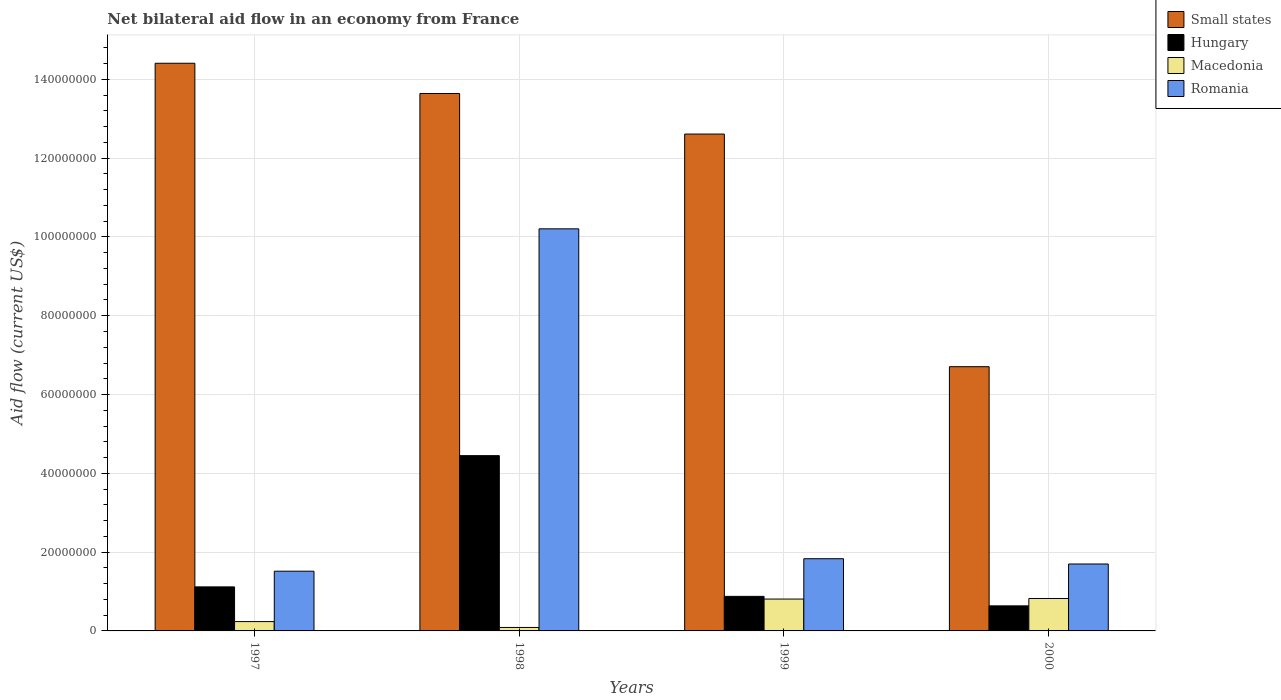How many different coloured bars are there?
Keep it short and to the point. 4. Are the number of bars per tick equal to the number of legend labels?
Keep it short and to the point. Yes. Are the number of bars on each tick of the X-axis equal?
Keep it short and to the point. Yes. How many bars are there on the 3rd tick from the left?
Provide a short and direct response. 4. How many bars are there on the 1st tick from the right?
Make the answer very short. 4. In how many cases, is the number of bars for a given year not equal to the number of legend labels?
Provide a short and direct response. 0. What is the net bilateral aid flow in Hungary in 1998?
Ensure brevity in your answer.  4.45e+07. Across all years, what is the maximum net bilateral aid flow in Small states?
Offer a very short reply. 1.44e+08. Across all years, what is the minimum net bilateral aid flow in Romania?
Offer a very short reply. 1.52e+07. In which year was the net bilateral aid flow in Macedonia maximum?
Your answer should be compact. 2000. What is the total net bilateral aid flow in Small states in the graph?
Ensure brevity in your answer.  4.74e+08. What is the difference between the net bilateral aid flow in Hungary in 1997 and that in 2000?
Give a very brief answer. 4.82e+06. What is the difference between the net bilateral aid flow in Romania in 1998 and the net bilateral aid flow in Hungary in 1999?
Provide a succinct answer. 9.33e+07. What is the average net bilateral aid flow in Romania per year?
Your response must be concise. 3.81e+07. In the year 1999, what is the difference between the net bilateral aid flow in Romania and net bilateral aid flow in Macedonia?
Give a very brief answer. 1.02e+07. In how many years, is the net bilateral aid flow in Small states greater than 60000000 US$?
Offer a terse response. 4. What is the ratio of the net bilateral aid flow in Hungary in 1998 to that in 1999?
Provide a short and direct response. 5.07. Is the net bilateral aid flow in Small states in 1998 less than that in 1999?
Offer a terse response. No. What is the difference between the highest and the lowest net bilateral aid flow in Macedonia?
Offer a very short reply. 7.35e+06. Is the sum of the net bilateral aid flow in Hungary in 1998 and 2000 greater than the maximum net bilateral aid flow in Small states across all years?
Your answer should be very brief. No. Is it the case that in every year, the sum of the net bilateral aid flow in Macedonia and net bilateral aid flow in Small states is greater than the sum of net bilateral aid flow in Romania and net bilateral aid flow in Hungary?
Your response must be concise. Yes. What does the 2nd bar from the left in 1998 represents?
Keep it short and to the point. Hungary. What does the 2nd bar from the right in 1997 represents?
Give a very brief answer. Macedonia. Is it the case that in every year, the sum of the net bilateral aid flow in Romania and net bilateral aid flow in Small states is greater than the net bilateral aid flow in Hungary?
Offer a very short reply. Yes. How many years are there in the graph?
Your answer should be compact. 4. What is the difference between two consecutive major ticks on the Y-axis?
Keep it short and to the point. 2.00e+07. Does the graph contain grids?
Offer a very short reply. Yes. Where does the legend appear in the graph?
Offer a terse response. Top right. What is the title of the graph?
Ensure brevity in your answer.  Net bilateral aid flow in an economy from France. What is the label or title of the Y-axis?
Offer a terse response. Aid flow (current US$). What is the Aid flow (current US$) in Small states in 1997?
Your response must be concise. 1.44e+08. What is the Aid flow (current US$) in Hungary in 1997?
Offer a terse response. 1.12e+07. What is the Aid flow (current US$) of Macedonia in 1997?
Your answer should be compact. 2.37e+06. What is the Aid flow (current US$) of Romania in 1997?
Offer a very short reply. 1.52e+07. What is the Aid flow (current US$) in Small states in 1998?
Keep it short and to the point. 1.36e+08. What is the Aid flow (current US$) in Hungary in 1998?
Your answer should be very brief. 4.45e+07. What is the Aid flow (current US$) in Macedonia in 1998?
Offer a very short reply. 8.80e+05. What is the Aid flow (current US$) in Romania in 1998?
Your answer should be compact. 1.02e+08. What is the Aid flow (current US$) in Small states in 1999?
Make the answer very short. 1.26e+08. What is the Aid flow (current US$) in Hungary in 1999?
Ensure brevity in your answer.  8.77e+06. What is the Aid flow (current US$) of Macedonia in 1999?
Your answer should be very brief. 8.09e+06. What is the Aid flow (current US$) of Romania in 1999?
Your response must be concise. 1.83e+07. What is the Aid flow (current US$) in Small states in 2000?
Ensure brevity in your answer.  6.71e+07. What is the Aid flow (current US$) in Hungary in 2000?
Offer a terse response. 6.36e+06. What is the Aid flow (current US$) in Macedonia in 2000?
Your answer should be compact. 8.23e+06. What is the Aid flow (current US$) of Romania in 2000?
Your response must be concise. 1.70e+07. Across all years, what is the maximum Aid flow (current US$) in Small states?
Give a very brief answer. 1.44e+08. Across all years, what is the maximum Aid flow (current US$) in Hungary?
Give a very brief answer. 4.45e+07. Across all years, what is the maximum Aid flow (current US$) in Macedonia?
Keep it short and to the point. 8.23e+06. Across all years, what is the maximum Aid flow (current US$) in Romania?
Make the answer very short. 1.02e+08. Across all years, what is the minimum Aid flow (current US$) of Small states?
Provide a short and direct response. 6.71e+07. Across all years, what is the minimum Aid flow (current US$) of Hungary?
Offer a very short reply. 6.36e+06. Across all years, what is the minimum Aid flow (current US$) in Macedonia?
Provide a succinct answer. 8.80e+05. Across all years, what is the minimum Aid flow (current US$) in Romania?
Provide a short and direct response. 1.52e+07. What is the total Aid flow (current US$) of Small states in the graph?
Offer a very short reply. 4.74e+08. What is the total Aid flow (current US$) of Hungary in the graph?
Give a very brief answer. 7.08e+07. What is the total Aid flow (current US$) of Macedonia in the graph?
Give a very brief answer. 1.96e+07. What is the total Aid flow (current US$) of Romania in the graph?
Your response must be concise. 1.53e+08. What is the difference between the Aid flow (current US$) of Small states in 1997 and that in 1998?
Give a very brief answer. 7.67e+06. What is the difference between the Aid flow (current US$) in Hungary in 1997 and that in 1998?
Ensure brevity in your answer.  -3.33e+07. What is the difference between the Aid flow (current US$) of Macedonia in 1997 and that in 1998?
Offer a very short reply. 1.49e+06. What is the difference between the Aid flow (current US$) of Romania in 1997 and that in 1998?
Make the answer very short. -8.69e+07. What is the difference between the Aid flow (current US$) of Small states in 1997 and that in 1999?
Provide a succinct answer. 1.80e+07. What is the difference between the Aid flow (current US$) of Hungary in 1997 and that in 1999?
Keep it short and to the point. 2.41e+06. What is the difference between the Aid flow (current US$) in Macedonia in 1997 and that in 1999?
Offer a very short reply. -5.72e+06. What is the difference between the Aid flow (current US$) in Romania in 1997 and that in 1999?
Offer a terse response. -3.17e+06. What is the difference between the Aid flow (current US$) of Small states in 1997 and that in 2000?
Provide a succinct answer. 7.70e+07. What is the difference between the Aid flow (current US$) in Hungary in 1997 and that in 2000?
Your answer should be very brief. 4.82e+06. What is the difference between the Aid flow (current US$) in Macedonia in 1997 and that in 2000?
Give a very brief answer. -5.86e+06. What is the difference between the Aid flow (current US$) in Romania in 1997 and that in 2000?
Provide a succinct answer. -1.83e+06. What is the difference between the Aid flow (current US$) in Small states in 1998 and that in 1999?
Offer a terse response. 1.03e+07. What is the difference between the Aid flow (current US$) of Hungary in 1998 and that in 1999?
Your response must be concise. 3.57e+07. What is the difference between the Aid flow (current US$) of Macedonia in 1998 and that in 1999?
Ensure brevity in your answer.  -7.21e+06. What is the difference between the Aid flow (current US$) in Romania in 1998 and that in 1999?
Offer a very short reply. 8.37e+07. What is the difference between the Aid flow (current US$) in Small states in 1998 and that in 2000?
Your answer should be very brief. 6.94e+07. What is the difference between the Aid flow (current US$) in Hungary in 1998 and that in 2000?
Your answer should be very brief. 3.81e+07. What is the difference between the Aid flow (current US$) of Macedonia in 1998 and that in 2000?
Your answer should be very brief. -7.35e+06. What is the difference between the Aid flow (current US$) of Romania in 1998 and that in 2000?
Your answer should be compact. 8.51e+07. What is the difference between the Aid flow (current US$) of Small states in 1999 and that in 2000?
Offer a very short reply. 5.90e+07. What is the difference between the Aid flow (current US$) in Hungary in 1999 and that in 2000?
Your response must be concise. 2.41e+06. What is the difference between the Aid flow (current US$) in Romania in 1999 and that in 2000?
Your answer should be compact. 1.34e+06. What is the difference between the Aid flow (current US$) of Small states in 1997 and the Aid flow (current US$) of Hungary in 1998?
Your answer should be compact. 9.96e+07. What is the difference between the Aid flow (current US$) in Small states in 1997 and the Aid flow (current US$) in Macedonia in 1998?
Give a very brief answer. 1.43e+08. What is the difference between the Aid flow (current US$) in Small states in 1997 and the Aid flow (current US$) in Romania in 1998?
Provide a short and direct response. 4.20e+07. What is the difference between the Aid flow (current US$) in Hungary in 1997 and the Aid flow (current US$) in Macedonia in 1998?
Your answer should be very brief. 1.03e+07. What is the difference between the Aid flow (current US$) in Hungary in 1997 and the Aid flow (current US$) in Romania in 1998?
Make the answer very short. -9.09e+07. What is the difference between the Aid flow (current US$) in Macedonia in 1997 and the Aid flow (current US$) in Romania in 1998?
Give a very brief answer. -9.97e+07. What is the difference between the Aid flow (current US$) of Small states in 1997 and the Aid flow (current US$) of Hungary in 1999?
Give a very brief answer. 1.35e+08. What is the difference between the Aid flow (current US$) of Small states in 1997 and the Aid flow (current US$) of Macedonia in 1999?
Your answer should be compact. 1.36e+08. What is the difference between the Aid flow (current US$) of Small states in 1997 and the Aid flow (current US$) of Romania in 1999?
Make the answer very short. 1.26e+08. What is the difference between the Aid flow (current US$) of Hungary in 1997 and the Aid flow (current US$) of Macedonia in 1999?
Your answer should be very brief. 3.09e+06. What is the difference between the Aid flow (current US$) of Hungary in 1997 and the Aid flow (current US$) of Romania in 1999?
Ensure brevity in your answer.  -7.15e+06. What is the difference between the Aid flow (current US$) in Macedonia in 1997 and the Aid flow (current US$) in Romania in 1999?
Offer a very short reply. -1.60e+07. What is the difference between the Aid flow (current US$) of Small states in 1997 and the Aid flow (current US$) of Hungary in 2000?
Your response must be concise. 1.38e+08. What is the difference between the Aid flow (current US$) in Small states in 1997 and the Aid flow (current US$) in Macedonia in 2000?
Provide a short and direct response. 1.36e+08. What is the difference between the Aid flow (current US$) of Small states in 1997 and the Aid flow (current US$) of Romania in 2000?
Make the answer very short. 1.27e+08. What is the difference between the Aid flow (current US$) of Hungary in 1997 and the Aid flow (current US$) of Macedonia in 2000?
Offer a terse response. 2.95e+06. What is the difference between the Aid flow (current US$) in Hungary in 1997 and the Aid flow (current US$) in Romania in 2000?
Provide a succinct answer. -5.81e+06. What is the difference between the Aid flow (current US$) in Macedonia in 1997 and the Aid flow (current US$) in Romania in 2000?
Your answer should be compact. -1.46e+07. What is the difference between the Aid flow (current US$) in Small states in 1998 and the Aid flow (current US$) in Hungary in 1999?
Provide a short and direct response. 1.28e+08. What is the difference between the Aid flow (current US$) of Small states in 1998 and the Aid flow (current US$) of Macedonia in 1999?
Give a very brief answer. 1.28e+08. What is the difference between the Aid flow (current US$) of Small states in 1998 and the Aid flow (current US$) of Romania in 1999?
Keep it short and to the point. 1.18e+08. What is the difference between the Aid flow (current US$) in Hungary in 1998 and the Aid flow (current US$) in Macedonia in 1999?
Your answer should be very brief. 3.64e+07. What is the difference between the Aid flow (current US$) in Hungary in 1998 and the Aid flow (current US$) in Romania in 1999?
Your response must be concise. 2.62e+07. What is the difference between the Aid flow (current US$) of Macedonia in 1998 and the Aid flow (current US$) of Romania in 1999?
Your response must be concise. -1.74e+07. What is the difference between the Aid flow (current US$) of Small states in 1998 and the Aid flow (current US$) of Hungary in 2000?
Your response must be concise. 1.30e+08. What is the difference between the Aid flow (current US$) in Small states in 1998 and the Aid flow (current US$) in Macedonia in 2000?
Offer a terse response. 1.28e+08. What is the difference between the Aid flow (current US$) of Small states in 1998 and the Aid flow (current US$) of Romania in 2000?
Offer a very short reply. 1.19e+08. What is the difference between the Aid flow (current US$) of Hungary in 1998 and the Aid flow (current US$) of Macedonia in 2000?
Give a very brief answer. 3.63e+07. What is the difference between the Aid flow (current US$) in Hungary in 1998 and the Aid flow (current US$) in Romania in 2000?
Your response must be concise. 2.75e+07. What is the difference between the Aid flow (current US$) in Macedonia in 1998 and the Aid flow (current US$) in Romania in 2000?
Your response must be concise. -1.61e+07. What is the difference between the Aid flow (current US$) in Small states in 1999 and the Aid flow (current US$) in Hungary in 2000?
Your answer should be very brief. 1.20e+08. What is the difference between the Aid flow (current US$) in Small states in 1999 and the Aid flow (current US$) in Macedonia in 2000?
Ensure brevity in your answer.  1.18e+08. What is the difference between the Aid flow (current US$) in Small states in 1999 and the Aid flow (current US$) in Romania in 2000?
Your response must be concise. 1.09e+08. What is the difference between the Aid flow (current US$) of Hungary in 1999 and the Aid flow (current US$) of Macedonia in 2000?
Keep it short and to the point. 5.40e+05. What is the difference between the Aid flow (current US$) of Hungary in 1999 and the Aid flow (current US$) of Romania in 2000?
Your answer should be compact. -8.22e+06. What is the difference between the Aid flow (current US$) of Macedonia in 1999 and the Aid flow (current US$) of Romania in 2000?
Provide a succinct answer. -8.90e+06. What is the average Aid flow (current US$) of Small states per year?
Provide a short and direct response. 1.18e+08. What is the average Aid flow (current US$) in Hungary per year?
Provide a short and direct response. 1.77e+07. What is the average Aid flow (current US$) of Macedonia per year?
Your answer should be very brief. 4.89e+06. What is the average Aid flow (current US$) of Romania per year?
Keep it short and to the point. 3.81e+07. In the year 1997, what is the difference between the Aid flow (current US$) in Small states and Aid flow (current US$) in Hungary?
Offer a very short reply. 1.33e+08. In the year 1997, what is the difference between the Aid flow (current US$) in Small states and Aid flow (current US$) in Macedonia?
Make the answer very short. 1.42e+08. In the year 1997, what is the difference between the Aid flow (current US$) in Small states and Aid flow (current US$) in Romania?
Provide a short and direct response. 1.29e+08. In the year 1997, what is the difference between the Aid flow (current US$) of Hungary and Aid flow (current US$) of Macedonia?
Ensure brevity in your answer.  8.81e+06. In the year 1997, what is the difference between the Aid flow (current US$) in Hungary and Aid flow (current US$) in Romania?
Provide a succinct answer. -3.98e+06. In the year 1997, what is the difference between the Aid flow (current US$) of Macedonia and Aid flow (current US$) of Romania?
Offer a terse response. -1.28e+07. In the year 1998, what is the difference between the Aid flow (current US$) in Small states and Aid flow (current US$) in Hungary?
Your response must be concise. 9.19e+07. In the year 1998, what is the difference between the Aid flow (current US$) of Small states and Aid flow (current US$) of Macedonia?
Make the answer very short. 1.36e+08. In the year 1998, what is the difference between the Aid flow (current US$) in Small states and Aid flow (current US$) in Romania?
Provide a succinct answer. 3.44e+07. In the year 1998, what is the difference between the Aid flow (current US$) of Hungary and Aid flow (current US$) of Macedonia?
Keep it short and to the point. 4.36e+07. In the year 1998, what is the difference between the Aid flow (current US$) of Hungary and Aid flow (current US$) of Romania?
Offer a terse response. -5.76e+07. In the year 1998, what is the difference between the Aid flow (current US$) in Macedonia and Aid flow (current US$) in Romania?
Ensure brevity in your answer.  -1.01e+08. In the year 1999, what is the difference between the Aid flow (current US$) in Small states and Aid flow (current US$) in Hungary?
Ensure brevity in your answer.  1.17e+08. In the year 1999, what is the difference between the Aid flow (current US$) of Small states and Aid flow (current US$) of Macedonia?
Your response must be concise. 1.18e+08. In the year 1999, what is the difference between the Aid flow (current US$) in Small states and Aid flow (current US$) in Romania?
Keep it short and to the point. 1.08e+08. In the year 1999, what is the difference between the Aid flow (current US$) in Hungary and Aid flow (current US$) in Macedonia?
Offer a terse response. 6.80e+05. In the year 1999, what is the difference between the Aid flow (current US$) in Hungary and Aid flow (current US$) in Romania?
Your answer should be compact. -9.56e+06. In the year 1999, what is the difference between the Aid flow (current US$) in Macedonia and Aid flow (current US$) in Romania?
Provide a short and direct response. -1.02e+07. In the year 2000, what is the difference between the Aid flow (current US$) of Small states and Aid flow (current US$) of Hungary?
Ensure brevity in your answer.  6.07e+07. In the year 2000, what is the difference between the Aid flow (current US$) of Small states and Aid flow (current US$) of Macedonia?
Your answer should be very brief. 5.88e+07. In the year 2000, what is the difference between the Aid flow (current US$) of Small states and Aid flow (current US$) of Romania?
Your response must be concise. 5.01e+07. In the year 2000, what is the difference between the Aid flow (current US$) in Hungary and Aid flow (current US$) in Macedonia?
Make the answer very short. -1.87e+06. In the year 2000, what is the difference between the Aid flow (current US$) of Hungary and Aid flow (current US$) of Romania?
Offer a very short reply. -1.06e+07. In the year 2000, what is the difference between the Aid flow (current US$) in Macedonia and Aid flow (current US$) in Romania?
Provide a short and direct response. -8.76e+06. What is the ratio of the Aid flow (current US$) in Small states in 1997 to that in 1998?
Provide a succinct answer. 1.06. What is the ratio of the Aid flow (current US$) of Hungary in 1997 to that in 1998?
Your answer should be compact. 0.25. What is the ratio of the Aid flow (current US$) of Macedonia in 1997 to that in 1998?
Provide a short and direct response. 2.69. What is the ratio of the Aid flow (current US$) of Romania in 1997 to that in 1998?
Keep it short and to the point. 0.15. What is the ratio of the Aid flow (current US$) of Small states in 1997 to that in 1999?
Offer a very short reply. 1.14. What is the ratio of the Aid flow (current US$) in Hungary in 1997 to that in 1999?
Your answer should be very brief. 1.27. What is the ratio of the Aid flow (current US$) in Macedonia in 1997 to that in 1999?
Offer a terse response. 0.29. What is the ratio of the Aid flow (current US$) of Romania in 1997 to that in 1999?
Your answer should be compact. 0.83. What is the ratio of the Aid flow (current US$) in Small states in 1997 to that in 2000?
Provide a short and direct response. 2.15. What is the ratio of the Aid flow (current US$) in Hungary in 1997 to that in 2000?
Keep it short and to the point. 1.76. What is the ratio of the Aid flow (current US$) in Macedonia in 1997 to that in 2000?
Your response must be concise. 0.29. What is the ratio of the Aid flow (current US$) of Romania in 1997 to that in 2000?
Provide a short and direct response. 0.89. What is the ratio of the Aid flow (current US$) in Small states in 1998 to that in 1999?
Your answer should be compact. 1.08. What is the ratio of the Aid flow (current US$) in Hungary in 1998 to that in 1999?
Give a very brief answer. 5.07. What is the ratio of the Aid flow (current US$) of Macedonia in 1998 to that in 1999?
Your answer should be very brief. 0.11. What is the ratio of the Aid flow (current US$) of Romania in 1998 to that in 1999?
Your answer should be very brief. 5.57. What is the ratio of the Aid flow (current US$) in Small states in 1998 to that in 2000?
Your response must be concise. 2.03. What is the ratio of the Aid flow (current US$) of Hungary in 1998 to that in 2000?
Offer a very short reply. 7. What is the ratio of the Aid flow (current US$) in Macedonia in 1998 to that in 2000?
Your answer should be compact. 0.11. What is the ratio of the Aid flow (current US$) of Romania in 1998 to that in 2000?
Keep it short and to the point. 6.01. What is the ratio of the Aid flow (current US$) of Small states in 1999 to that in 2000?
Your answer should be compact. 1.88. What is the ratio of the Aid flow (current US$) of Hungary in 1999 to that in 2000?
Your response must be concise. 1.38. What is the ratio of the Aid flow (current US$) of Romania in 1999 to that in 2000?
Ensure brevity in your answer.  1.08. What is the difference between the highest and the second highest Aid flow (current US$) of Small states?
Keep it short and to the point. 7.67e+06. What is the difference between the highest and the second highest Aid flow (current US$) in Hungary?
Your response must be concise. 3.33e+07. What is the difference between the highest and the second highest Aid flow (current US$) in Macedonia?
Your response must be concise. 1.40e+05. What is the difference between the highest and the second highest Aid flow (current US$) of Romania?
Your response must be concise. 8.37e+07. What is the difference between the highest and the lowest Aid flow (current US$) in Small states?
Ensure brevity in your answer.  7.70e+07. What is the difference between the highest and the lowest Aid flow (current US$) of Hungary?
Ensure brevity in your answer.  3.81e+07. What is the difference between the highest and the lowest Aid flow (current US$) of Macedonia?
Your answer should be very brief. 7.35e+06. What is the difference between the highest and the lowest Aid flow (current US$) in Romania?
Offer a terse response. 8.69e+07. 